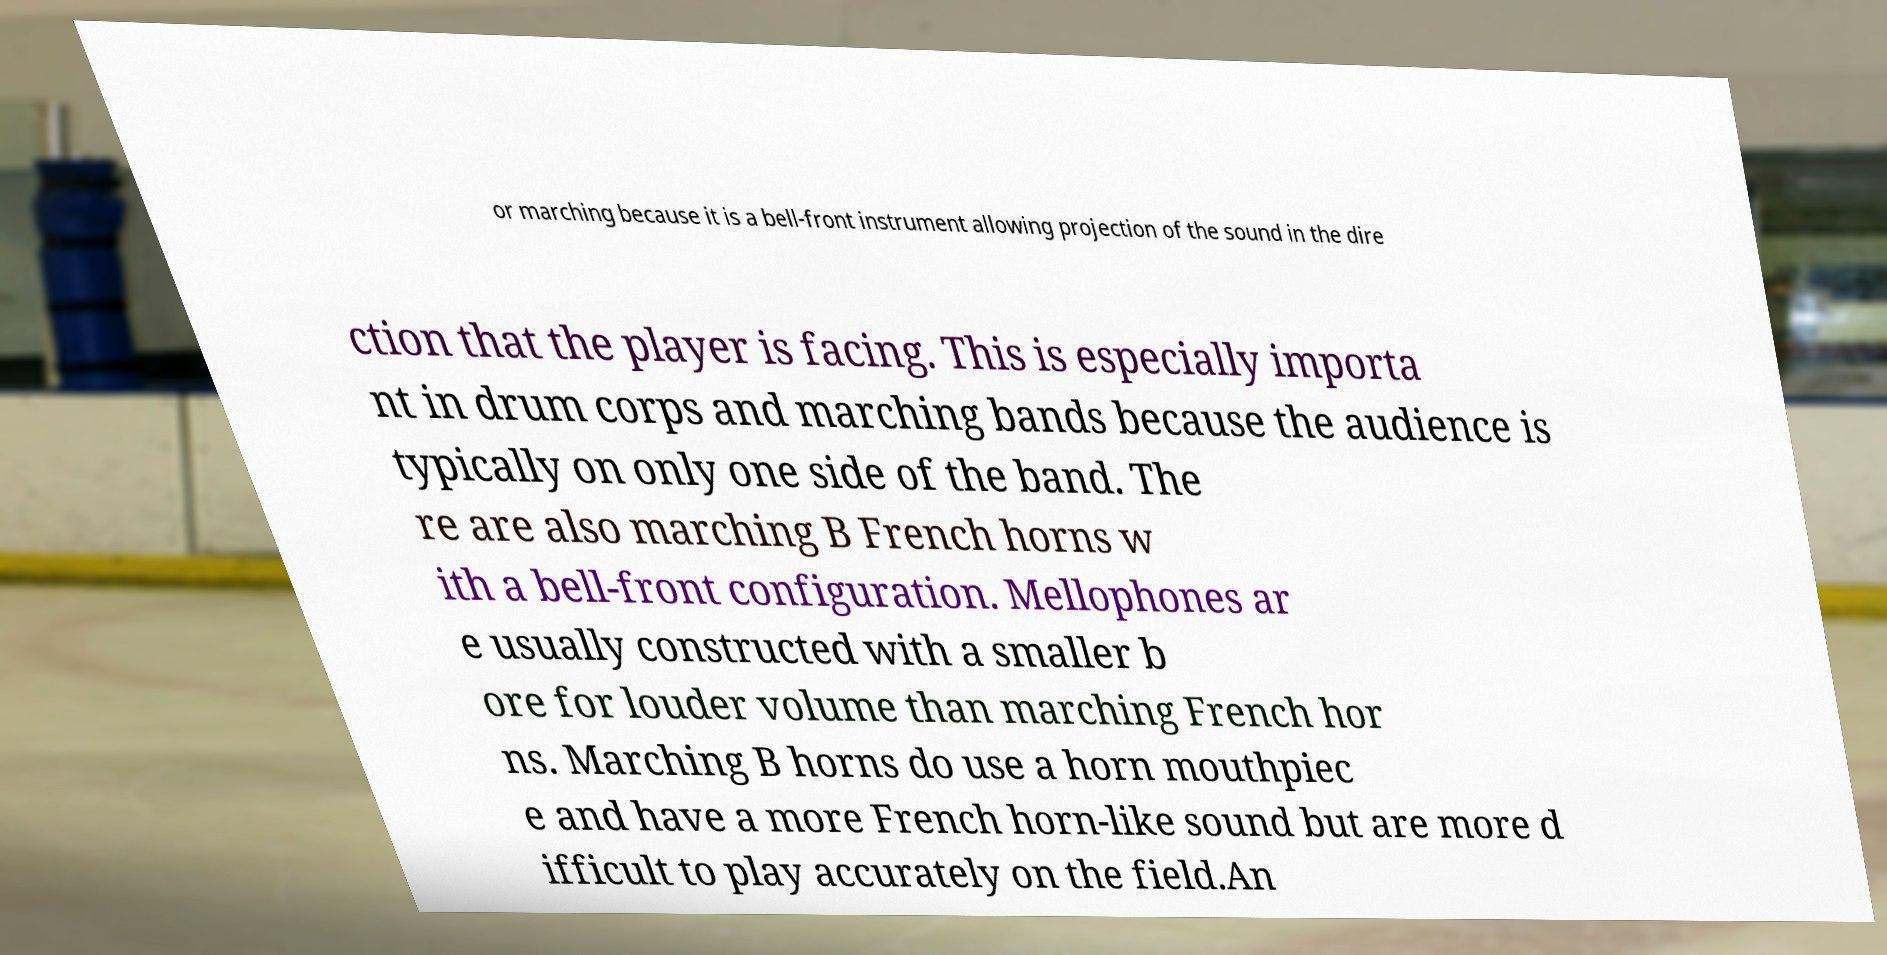Could you assist in decoding the text presented in this image and type it out clearly? or marching because it is a bell-front instrument allowing projection of the sound in the dire ction that the player is facing. This is especially importa nt in drum corps and marching bands because the audience is typically on only one side of the band. The re are also marching B French horns w ith a bell-front configuration. Mellophones ar e usually constructed with a smaller b ore for louder volume than marching French hor ns. Marching B horns do use a horn mouthpiec e and have a more French horn-like sound but are more d ifficult to play accurately on the field.An 